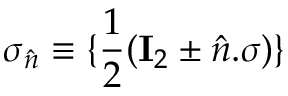<formula> <loc_0><loc_0><loc_500><loc_500>\sigma _ { \hat { n } } \equiv \{ \frac { 1 } { 2 } ( I _ { 2 } \pm \hat { n } . \sigma ) \}</formula> 